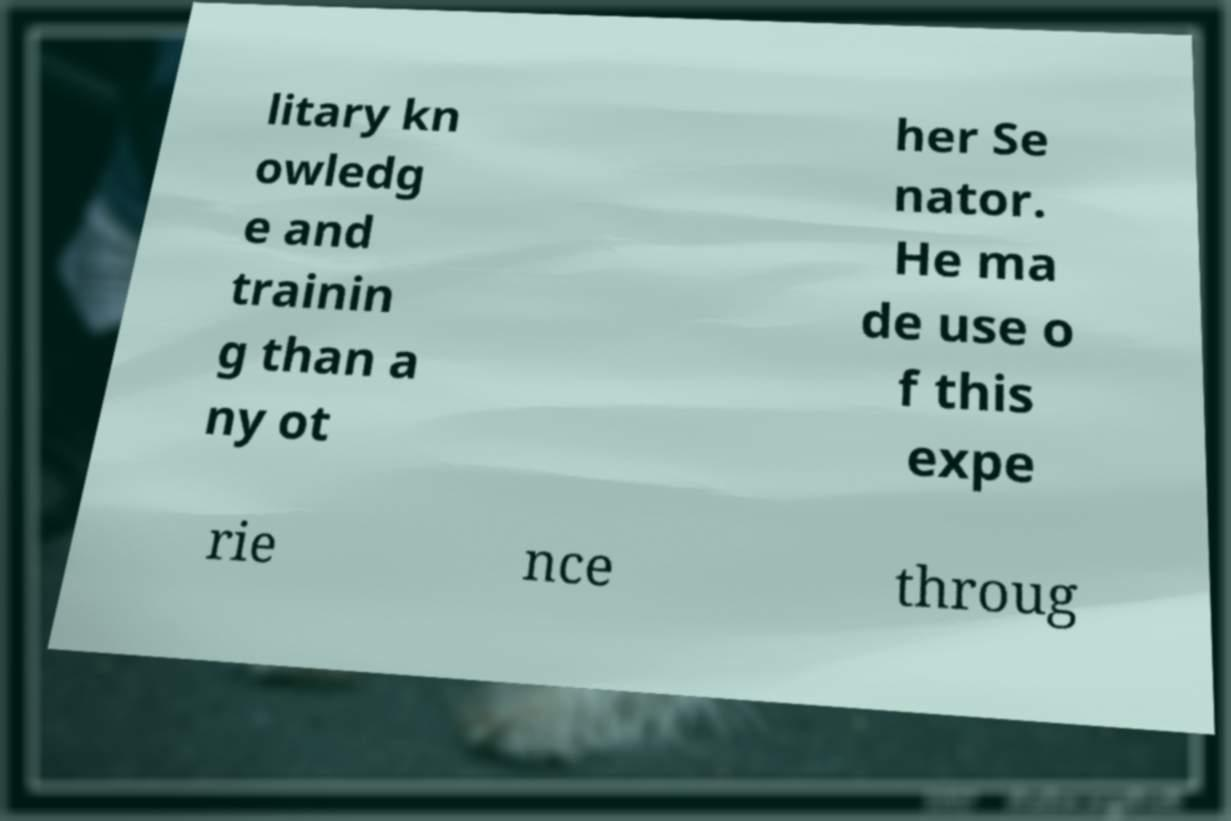There's text embedded in this image that I need extracted. Can you transcribe it verbatim? litary kn owledg e and trainin g than a ny ot her Se nator. He ma de use o f this expe rie nce throug 